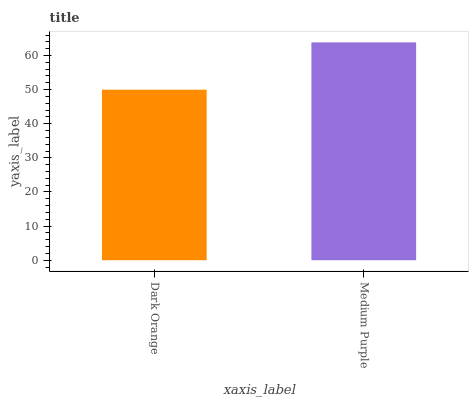Is Medium Purple the minimum?
Answer yes or no. No. Is Medium Purple greater than Dark Orange?
Answer yes or no. Yes. Is Dark Orange less than Medium Purple?
Answer yes or no. Yes. Is Dark Orange greater than Medium Purple?
Answer yes or no. No. Is Medium Purple less than Dark Orange?
Answer yes or no. No. Is Medium Purple the high median?
Answer yes or no. Yes. Is Dark Orange the low median?
Answer yes or no. Yes. Is Dark Orange the high median?
Answer yes or no. No. Is Medium Purple the low median?
Answer yes or no. No. 